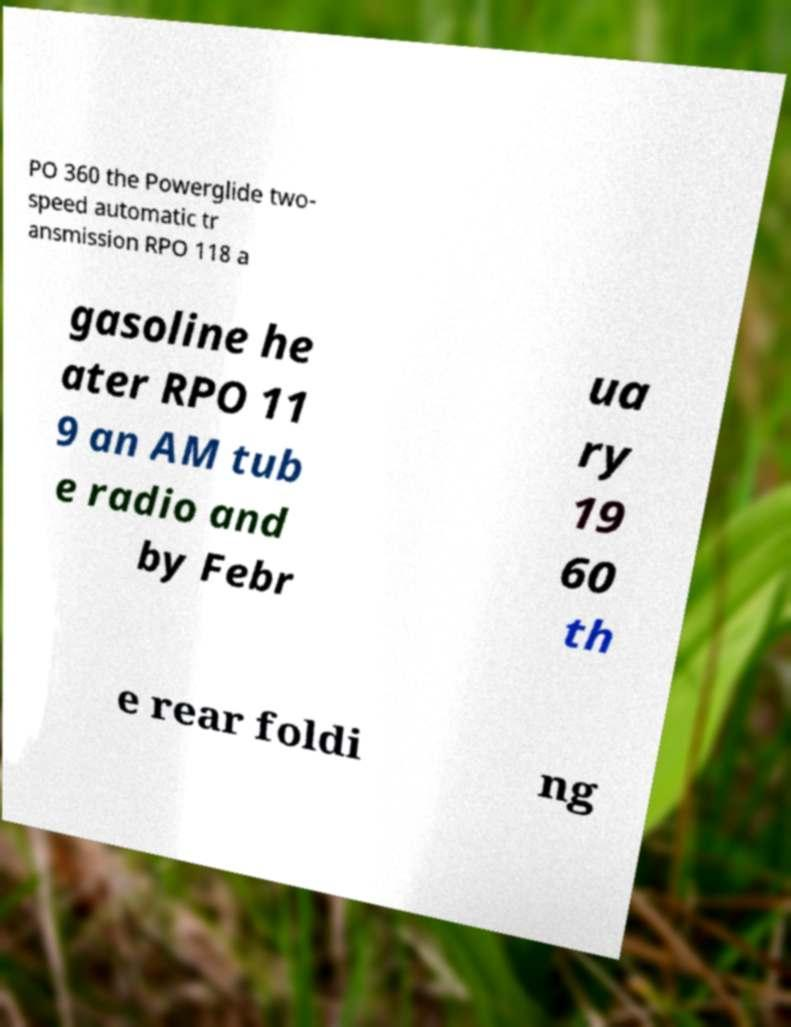There's text embedded in this image that I need extracted. Can you transcribe it verbatim? PO 360 the Powerglide two- speed automatic tr ansmission RPO 118 a gasoline he ater RPO 11 9 an AM tub e radio and by Febr ua ry 19 60 th e rear foldi ng 